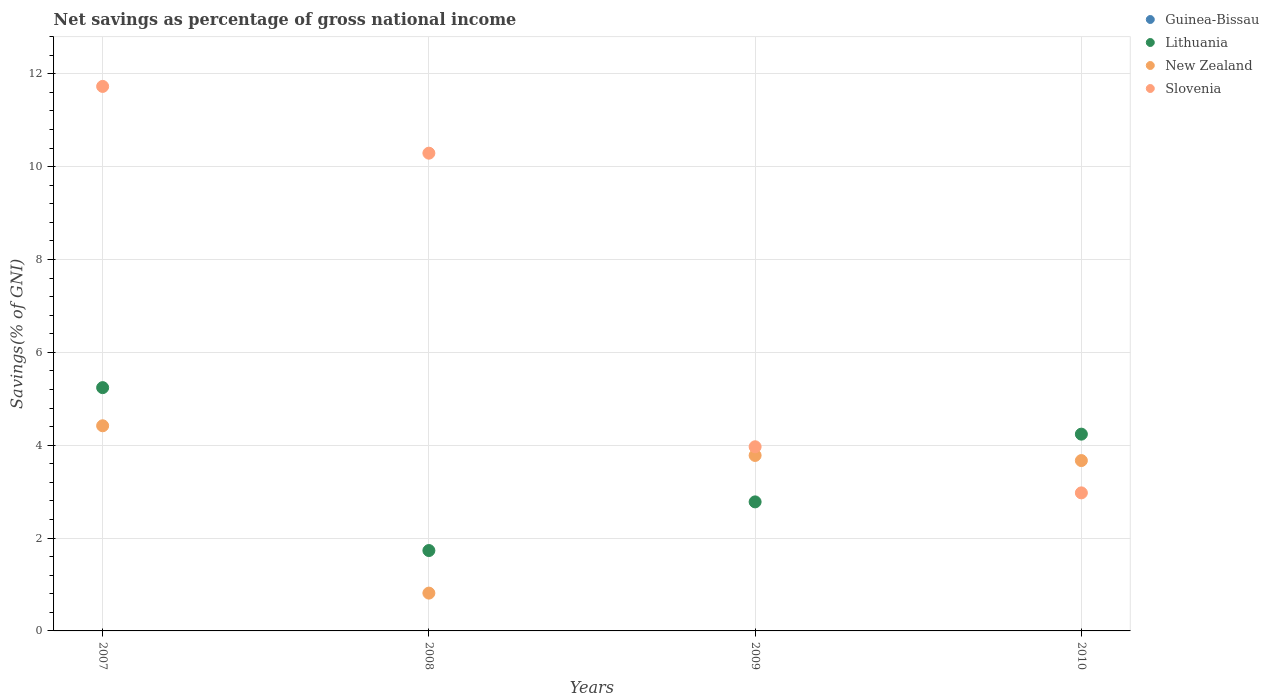Is the number of dotlines equal to the number of legend labels?
Make the answer very short. No. What is the total savings in Lithuania in 2007?
Offer a terse response. 5.24. Across all years, what is the maximum total savings in New Zealand?
Offer a terse response. 4.42. Across all years, what is the minimum total savings in Lithuania?
Offer a very short reply. 1.73. In which year was the total savings in Slovenia maximum?
Make the answer very short. 2007. What is the total total savings in New Zealand in the graph?
Ensure brevity in your answer.  12.68. What is the difference between the total savings in Slovenia in 2008 and that in 2009?
Ensure brevity in your answer.  6.32. What is the difference between the total savings in Guinea-Bissau in 2008 and the total savings in New Zealand in 2010?
Your answer should be very brief. -3.67. What is the average total savings in New Zealand per year?
Offer a terse response. 3.17. In the year 2008, what is the difference between the total savings in Lithuania and total savings in New Zealand?
Your answer should be compact. 0.92. What is the ratio of the total savings in New Zealand in 2008 to that in 2009?
Your response must be concise. 0.22. Is the difference between the total savings in Lithuania in 2008 and 2010 greater than the difference between the total savings in New Zealand in 2008 and 2010?
Ensure brevity in your answer.  Yes. What is the difference between the highest and the second highest total savings in New Zealand?
Your response must be concise. 0.64. What is the difference between the highest and the lowest total savings in Lithuania?
Your answer should be very brief. 3.51. Is the sum of the total savings in Lithuania in 2009 and 2010 greater than the maximum total savings in Guinea-Bissau across all years?
Your answer should be very brief. Yes. Is it the case that in every year, the sum of the total savings in New Zealand and total savings in Lithuania  is greater than the sum of total savings in Slovenia and total savings in Guinea-Bissau?
Offer a terse response. No. Is it the case that in every year, the sum of the total savings in Guinea-Bissau and total savings in Slovenia  is greater than the total savings in Lithuania?
Make the answer very short. No. Is the total savings in New Zealand strictly less than the total savings in Lithuania over the years?
Offer a terse response. No. What is the difference between two consecutive major ticks on the Y-axis?
Ensure brevity in your answer.  2. Are the values on the major ticks of Y-axis written in scientific E-notation?
Keep it short and to the point. No. Does the graph contain grids?
Provide a succinct answer. Yes. How are the legend labels stacked?
Provide a short and direct response. Vertical. What is the title of the graph?
Ensure brevity in your answer.  Net savings as percentage of gross national income. Does "Bahrain" appear as one of the legend labels in the graph?
Your response must be concise. No. What is the label or title of the Y-axis?
Make the answer very short. Savings(% of GNI). What is the Savings(% of GNI) in Lithuania in 2007?
Keep it short and to the point. 5.24. What is the Savings(% of GNI) in New Zealand in 2007?
Ensure brevity in your answer.  4.42. What is the Savings(% of GNI) in Slovenia in 2007?
Ensure brevity in your answer.  11.73. What is the Savings(% of GNI) of Lithuania in 2008?
Your response must be concise. 1.73. What is the Savings(% of GNI) in New Zealand in 2008?
Ensure brevity in your answer.  0.81. What is the Savings(% of GNI) in Slovenia in 2008?
Your answer should be very brief. 10.29. What is the Savings(% of GNI) of Lithuania in 2009?
Your answer should be very brief. 2.78. What is the Savings(% of GNI) in New Zealand in 2009?
Ensure brevity in your answer.  3.78. What is the Savings(% of GNI) in Slovenia in 2009?
Make the answer very short. 3.97. What is the Savings(% of GNI) in Guinea-Bissau in 2010?
Ensure brevity in your answer.  0. What is the Savings(% of GNI) of Lithuania in 2010?
Ensure brevity in your answer.  4.24. What is the Savings(% of GNI) in New Zealand in 2010?
Provide a succinct answer. 3.67. What is the Savings(% of GNI) of Slovenia in 2010?
Offer a very short reply. 2.97. Across all years, what is the maximum Savings(% of GNI) in Lithuania?
Offer a terse response. 5.24. Across all years, what is the maximum Savings(% of GNI) of New Zealand?
Offer a terse response. 4.42. Across all years, what is the maximum Savings(% of GNI) in Slovenia?
Provide a succinct answer. 11.73. Across all years, what is the minimum Savings(% of GNI) of Lithuania?
Your response must be concise. 1.73. Across all years, what is the minimum Savings(% of GNI) in New Zealand?
Your answer should be compact. 0.81. Across all years, what is the minimum Savings(% of GNI) of Slovenia?
Offer a terse response. 2.97. What is the total Savings(% of GNI) in Lithuania in the graph?
Your answer should be very brief. 13.99. What is the total Savings(% of GNI) in New Zealand in the graph?
Give a very brief answer. 12.68. What is the total Savings(% of GNI) in Slovenia in the graph?
Make the answer very short. 28.96. What is the difference between the Savings(% of GNI) of Lithuania in 2007 and that in 2008?
Your answer should be compact. 3.51. What is the difference between the Savings(% of GNI) of New Zealand in 2007 and that in 2008?
Your answer should be compact. 3.6. What is the difference between the Savings(% of GNI) of Slovenia in 2007 and that in 2008?
Make the answer very short. 1.44. What is the difference between the Savings(% of GNI) in Lithuania in 2007 and that in 2009?
Your answer should be compact. 2.46. What is the difference between the Savings(% of GNI) of New Zealand in 2007 and that in 2009?
Provide a short and direct response. 0.64. What is the difference between the Savings(% of GNI) in Slovenia in 2007 and that in 2009?
Your response must be concise. 7.76. What is the difference between the Savings(% of GNI) of Lithuania in 2007 and that in 2010?
Ensure brevity in your answer.  1. What is the difference between the Savings(% of GNI) of New Zealand in 2007 and that in 2010?
Provide a short and direct response. 0.75. What is the difference between the Savings(% of GNI) in Slovenia in 2007 and that in 2010?
Offer a terse response. 8.76. What is the difference between the Savings(% of GNI) in Lithuania in 2008 and that in 2009?
Your response must be concise. -1.05. What is the difference between the Savings(% of GNI) of New Zealand in 2008 and that in 2009?
Give a very brief answer. -2.97. What is the difference between the Savings(% of GNI) of Slovenia in 2008 and that in 2009?
Ensure brevity in your answer.  6.32. What is the difference between the Savings(% of GNI) of Lithuania in 2008 and that in 2010?
Your response must be concise. -2.51. What is the difference between the Savings(% of GNI) in New Zealand in 2008 and that in 2010?
Give a very brief answer. -2.85. What is the difference between the Savings(% of GNI) of Slovenia in 2008 and that in 2010?
Your answer should be compact. 7.32. What is the difference between the Savings(% of GNI) of Lithuania in 2009 and that in 2010?
Provide a short and direct response. -1.46. What is the difference between the Savings(% of GNI) of New Zealand in 2009 and that in 2010?
Ensure brevity in your answer.  0.11. What is the difference between the Savings(% of GNI) of Lithuania in 2007 and the Savings(% of GNI) of New Zealand in 2008?
Ensure brevity in your answer.  4.43. What is the difference between the Savings(% of GNI) in Lithuania in 2007 and the Savings(% of GNI) in Slovenia in 2008?
Your answer should be very brief. -5.05. What is the difference between the Savings(% of GNI) in New Zealand in 2007 and the Savings(% of GNI) in Slovenia in 2008?
Give a very brief answer. -5.87. What is the difference between the Savings(% of GNI) in Lithuania in 2007 and the Savings(% of GNI) in New Zealand in 2009?
Make the answer very short. 1.46. What is the difference between the Savings(% of GNI) in Lithuania in 2007 and the Savings(% of GNI) in Slovenia in 2009?
Ensure brevity in your answer.  1.27. What is the difference between the Savings(% of GNI) in New Zealand in 2007 and the Savings(% of GNI) in Slovenia in 2009?
Make the answer very short. 0.45. What is the difference between the Savings(% of GNI) of Lithuania in 2007 and the Savings(% of GNI) of New Zealand in 2010?
Offer a very short reply. 1.57. What is the difference between the Savings(% of GNI) in Lithuania in 2007 and the Savings(% of GNI) in Slovenia in 2010?
Provide a short and direct response. 2.27. What is the difference between the Savings(% of GNI) of New Zealand in 2007 and the Savings(% of GNI) of Slovenia in 2010?
Provide a succinct answer. 1.45. What is the difference between the Savings(% of GNI) of Lithuania in 2008 and the Savings(% of GNI) of New Zealand in 2009?
Your answer should be compact. -2.05. What is the difference between the Savings(% of GNI) in Lithuania in 2008 and the Savings(% of GNI) in Slovenia in 2009?
Your answer should be very brief. -2.24. What is the difference between the Savings(% of GNI) in New Zealand in 2008 and the Savings(% of GNI) in Slovenia in 2009?
Your answer should be compact. -3.15. What is the difference between the Savings(% of GNI) in Lithuania in 2008 and the Savings(% of GNI) in New Zealand in 2010?
Keep it short and to the point. -1.94. What is the difference between the Savings(% of GNI) in Lithuania in 2008 and the Savings(% of GNI) in Slovenia in 2010?
Give a very brief answer. -1.24. What is the difference between the Savings(% of GNI) in New Zealand in 2008 and the Savings(% of GNI) in Slovenia in 2010?
Offer a very short reply. -2.16. What is the difference between the Savings(% of GNI) of Lithuania in 2009 and the Savings(% of GNI) of New Zealand in 2010?
Your answer should be compact. -0.89. What is the difference between the Savings(% of GNI) in Lithuania in 2009 and the Savings(% of GNI) in Slovenia in 2010?
Give a very brief answer. -0.19. What is the difference between the Savings(% of GNI) in New Zealand in 2009 and the Savings(% of GNI) in Slovenia in 2010?
Your answer should be very brief. 0.81. What is the average Savings(% of GNI) in Lithuania per year?
Your answer should be very brief. 3.5. What is the average Savings(% of GNI) in New Zealand per year?
Your response must be concise. 3.17. What is the average Savings(% of GNI) in Slovenia per year?
Provide a short and direct response. 7.24. In the year 2007, what is the difference between the Savings(% of GNI) in Lithuania and Savings(% of GNI) in New Zealand?
Provide a succinct answer. 0.82. In the year 2007, what is the difference between the Savings(% of GNI) in Lithuania and Savings(% of GNI) in Slovenia?
Keep it short and to the point. -6.49. In the year 2007, what is the difference between the Savings(% of GNI) of New Zealand and Savings(% of GNI) of Slovenia?
Your answer should be very brief. -7.31. In the year 2008, what is the difference between the Savings(% of GNI) of Lithuania and Savings(% of GNI) of New Zealand?
Your response must be concise. 0.92. In the year 2008, what is the difference between the Savings(% of GNI) of Lithuania and Savings(% of GNI) of Slovenia?
Provide a short and direct response. -8.56. In the year 2008, what is the difference between the Savings(% of GNI) in New Zealand and Savings(% of GNI) in Slovenia?
Make the answer very short. -9.48. In the year 2009, what is the difference between the Savings(% of GNI) in Lithuania and Savings(% of GNI) in New Zealand?
Offer a terse response. -1. In the year 2009, what is the difference between the Savings(% of GNI) in Lithuania and Savings(% of GNI) in Slovenia?
Make the answer very short. -1.19. In the year 2009, what is the difference between the Savings(% of GNI) of New Zealand and Savings(% of GNI) of Slovenia?
Ensure brevity in your answer.  -0.19. In the year 2010, what is the difference between the Savings(% of GNI) of Lithuania and Savings(% of GNI) of New Zealand?
Your answer should be compact. 0.57. In the year 2010, what is the difference between the Savings(% of GNI) of Lithuania and Savings(% of GNI) of Slovenia?
Keep it short and to the point. 1.26. In the year 2010, what is the difference between the Savings(% of GNI) of New Zealand and Savings(% of GNI) of Slovenia?
Give a very brief answer. 0.7. What is the ratio of the Savings(% of GNI) of Lithuania in 2007 to that in 2008?
Ensure brevity in your answer.  3.03. What is the ratio of the Savings(% of GNI) in New Zealand in 2007 to that in 2008?
Your answer should be very brief. 5.43. What is the ratio of the Savings(% of GNI) of Slovenia in 2007 to that in 2008?
Offer a terse response. 1.14. What is the ratio of the Savings(% of GNI) in Lithuania in 2007 to that in 2009?
Keep it short and to the point. 1.89. What is the ratio of the Savings(% of GNI) in New Zealand in 2007 to that in 2009?
Your response must be concise. 1.17. What is the ratio of the Savings(% of GNI) in Slovenia in 2007 to that in 2009?
Offer a terse response. 2.96. What is the ratio of the Savings(% of GNI) in Lithuania in 2007 to that in 2010?
Offer a very short reply. 1.24. What is the ratio of the Savings(% of GNI) in New Zealand in 2007 to that in 2010?
Your response must be concise. 1.2. What is the ratio of the Savings(% of GNI) in Slovenia in 2007 to that in 2010?
Provide a short and direct response. 3.94. What is the ratio of the Savings(% of GNI) in Lithuania in 2008 to that in 2009?
Give a very brief answer. 0.62. What is the ratio of the Savings(% of GNI) of New Zealand in 2008 to that in 2009?
Your answer should be compact. 0.22. What is the ratio of the Savings(% of GNI) in Slovenia in 2008 to that in 2009?
Offer a very short reply. 2.59. What is the ratio of the Savings(% of GNI) in Lithuania in 2008 to that in 2010?
Your answer should be very brief. 0.41. What is the ratio of the Savings(% of GNI) of New Zealand in 2008 to that in 2010?
Make the answer very short. 0.22. What is the ratio of the Savings(% of GNI) of Slovenia in 2008 to that in 2010?
Give a very brief answer. 3.46. What is the ratio of the Savings(% of GNI) of Lithuania in 2009 to that in 2010?
Your answer should be very brief. 0.66. What is the ratio of the Savings(% of GNI) of New Zealand in 2009 to that in 2010?
Your answer should be compact. 1.03. What is the ratio of the Savings(% of GNI) in Slovenia in 2009 to that in 2010?
Your answer should be very brief. 1.33. What is the difference between the highest and the second highest Savings(% of GNI) of New Zealand?
Provide a succinct answer. 0.64. What is the difference between the highest and the second highest Savings(% of GNI) of Slovenia?
Your answer should be compact. 1.44. What is the difference between the highest and the lowest Savings(% of GNI) in Lithuania?
Offer a very short reply. 3.51. What is the difference between the highest and the lowest Savings(% of GNI) of New Zealand?
Offer a terse response. 3.6. What is the difference between the highest and the lowest Savings(% of GNI) in Slovenia?
Your answer should be compact. 8.76. 